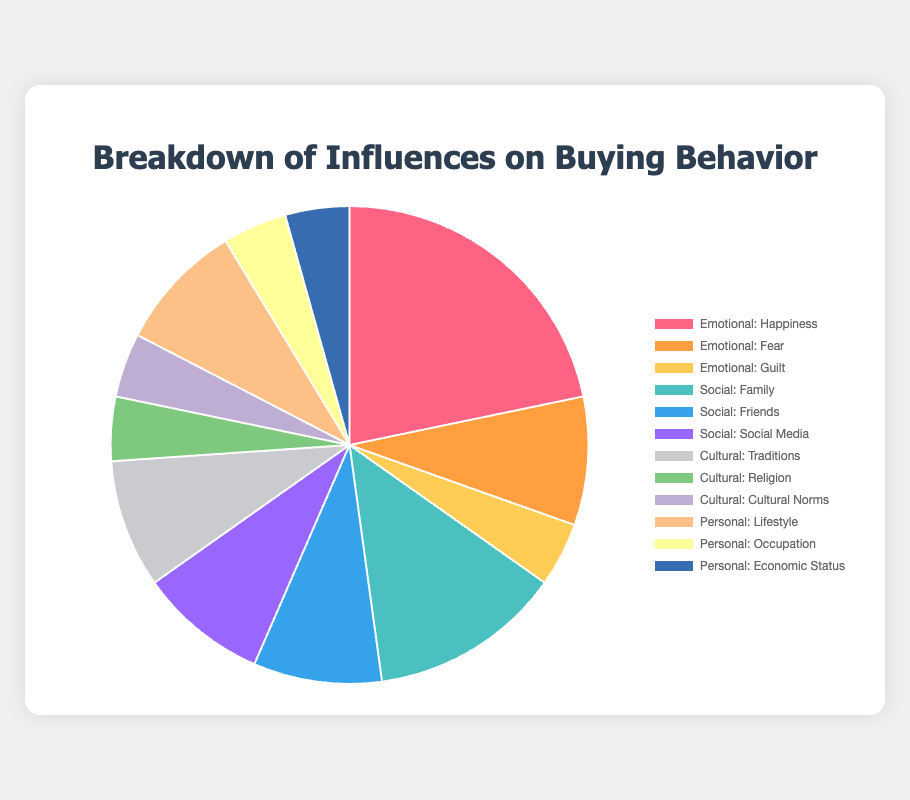What percentage of the total influence on buying behavior does the Emotional category have? Add the contributions from the Emotional category factors: Happiness (25), Fear (10), and Guilt (5). The total for Emotional is 25 + 10 + 5 = 40%.
Answer: 40% Which factor has the highest contribution within the Social category? Compare the contributions of Family (15), Friends (10), and Social Media (10). The highest value is for Family.
Answer: Family How do the contributions of Happiness and Guilt compare? Happiness contributes 25% and Guilt contributes 5%. By subtracting the smaller from the larger, we see that Happiness contributes 20% more than Guilt.
Answer: 20% more Which factor has the lowest contribution in the entire dataset? Identify the factor with the smallest percentage: Guilt (5%), Religion (5%), Cultural Norms (5%), Occupation (5%), Economic Status (5%). All these factors contribute equally and are the lowest.
Answer: Guilt, Religion, Cultural Norms, Occupation, Economic Status What's the combined contribution of Family and Friends within the Social category? Add the contributions of Family (15) and Friends (10). The combined contribution is 15 + 10 = 25%.
Answer: 25% What is the total contribution of all Personal factors combined? Add the contributions from the Personal category factors: Lifestyle (10), Occupation (5), and Economic Status (5). The total is 10 + 5 + 5 = 20%.
Answer: 20% How does the total contribution of Social compare to Cultural? Add contributions of Social factors: Family (15), Friends (10), and Social Media (10) giving 35%. Add contributions of Cultural factors: Traditions (10), Religion (5), and Cultural Norms (5) giving 20%. Social (35%) is greater than Cultural (20%).
Answer: Social is 15% greater What is the average contribution of factors in the Cultural category? Add contributions in the Cultural category: Traditions (10), Religion (5), Cultural Norms (5) to get 20%. There are 3 factors, so the average is 20/3 ≈ 6.67%.
Answer: ≈ 6.67% Which factors have a contribution of 10% or more? Identify factors with contributions of 10% or more: Happiness (25), Fear (10), Family (15), Friends (10), Social Media (10), and Traditions (10).
Answer: Happiness, Fear, Family, Friends, Social Media, Traditions 